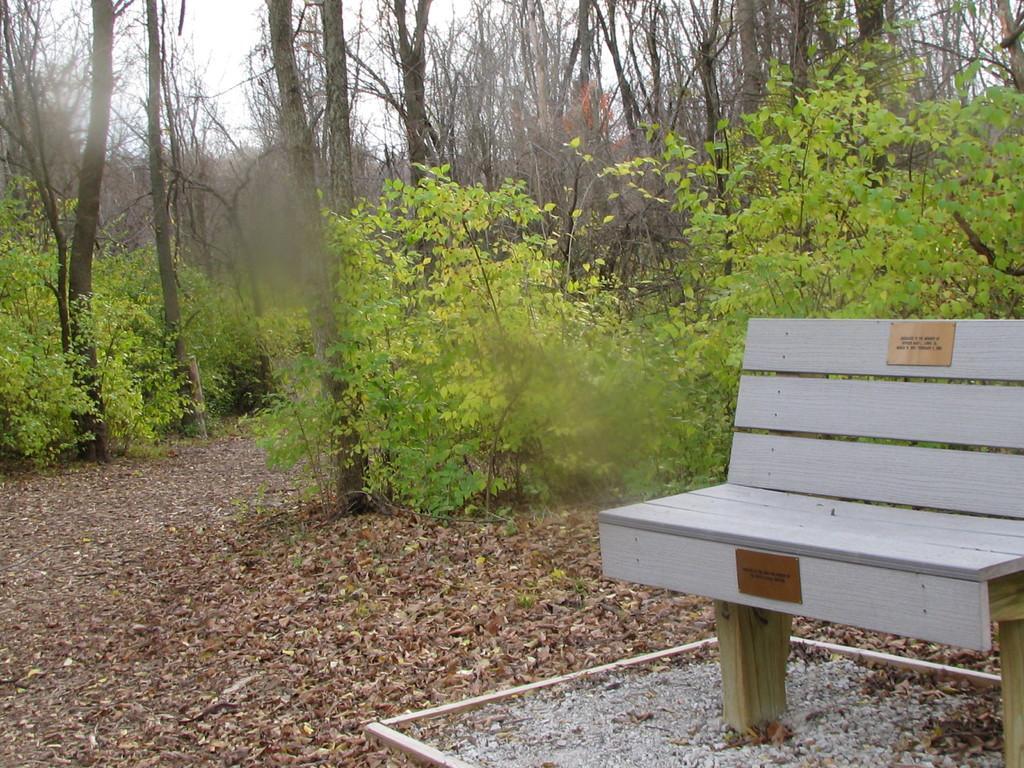Describe this image in one or two sentences. In this image I can see the bench. To the side of the bench I can see many trees and I can see the white sky. 